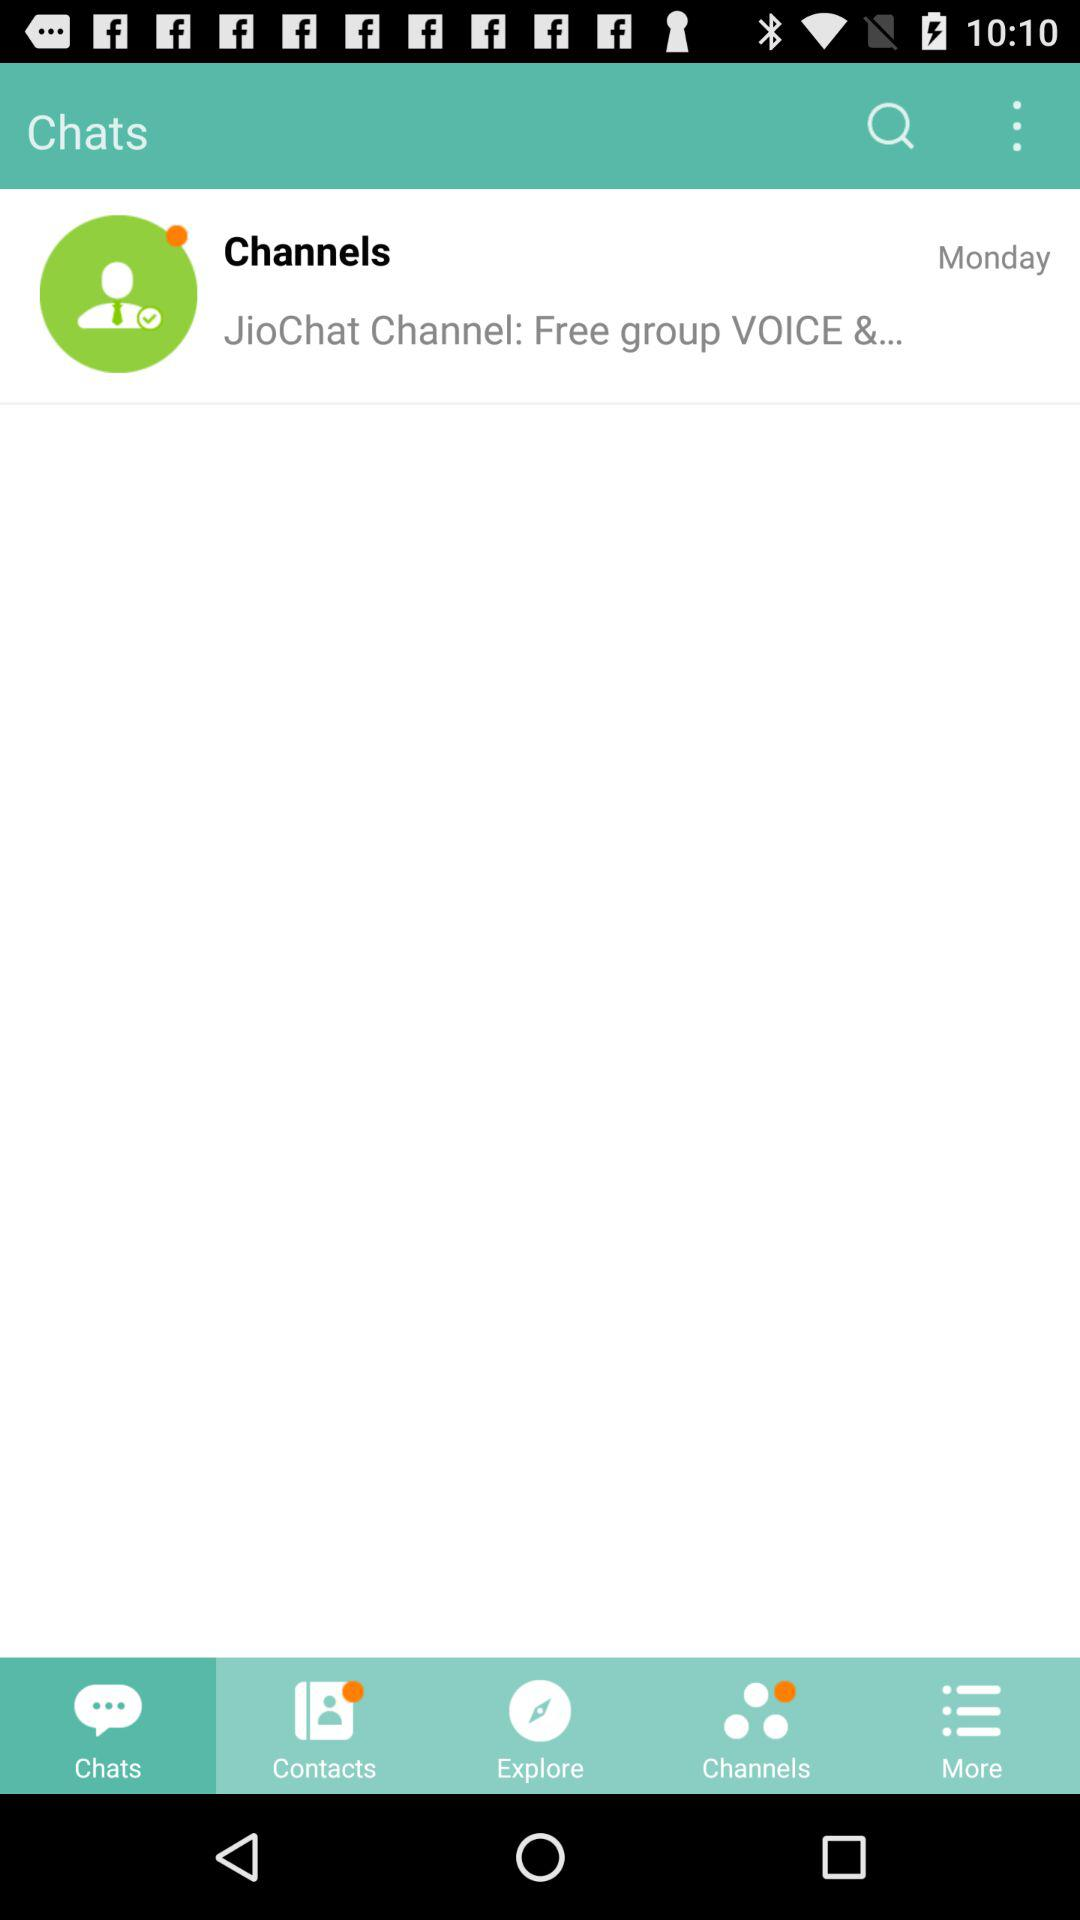Which tab is selected? The selected tab is chats. 